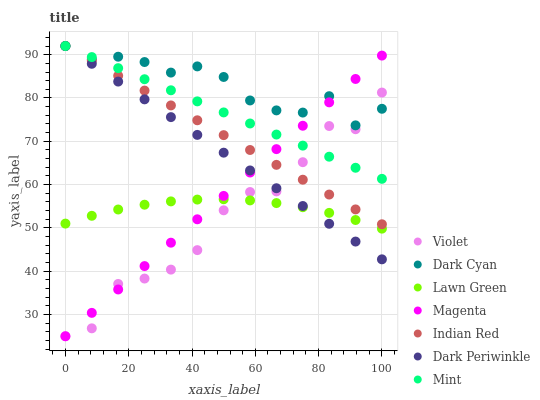Does Violet have the minimum area under the curve?
Answer yes or no. Yes. Does Dark Cyan have the maximum area under the curve?
Answer yes or no. Yes. Does Indian Red have the minimum area under the curve?
Answer yes or no. No. Does Indian Red have the maximum area under the curve?
Answer yes or no. No. Is Mint the smoothest?
Answer yes or no. Yes. Is Violet the roughest?
Answer yes or no. Yes. Is Indian Red the smoothest?
Answer yes or no. No. Is Indian Red the roughest?
Answer yes or no. No. Does Violet have the lowest value?
Answer yes or no. Yes. Does Indian Red have the lowest value?
Answer yes or no. No. Does Dark Periwinkle have the highest value?
Answer yes or no. Yes. Does Violet have the highest value?
Answer yes or no. No. Is Lawn Green less than Dark Cyan?
Answer yes or no. Yes. Is Mint greater than Lawn Green?
Answer yes or no. Yes. Does Dark Periwinkle intersect Lawn Green?
Answer yes or no. Yes. Is Dark Periwinkle less than Lawn Green?
Answer yes or no. No. Is Dark Periwinkle greater than Lawn Green?
Answer yes or no. No. Does Lawn Green intersect Dark Cyan?
Answer yes or no. No. 